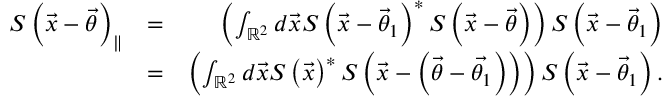Convert formula to latex. <formula><loc_0><loc_0><loc_500><loc_500>\begin{array} { r l r } { S \left ( \vec { x } - \vec { \theta } \right ) _ { \| } } & { = } & { \left ( \int _ { \mathbb { R } ^ { 2 } } d \vec { x } S \left ( \vec { x } - \vec { \theta } _ { 1 } \right ) ^ { \ast } S \left ( \vec { x } - \vec { \theta } \right ) \right ) S \left ( \vec { x } - \vec { \theta } _ { 1 } \right ) } \\ & { = } & { \left ( \int _ { \mathbb { R } ^ { 2 } } d \vec { x } S \left ( \vec { x } \right ) ^ { \ast } S \left ( \vec { x } - \left ( \vec { \theta } - \vec { \theta _ { 1 } } \right ) \right ) \right ) S \left ( \vec { x } - \vec { \theta } _ { 1 } \right ) . } \end{array}</formula> 